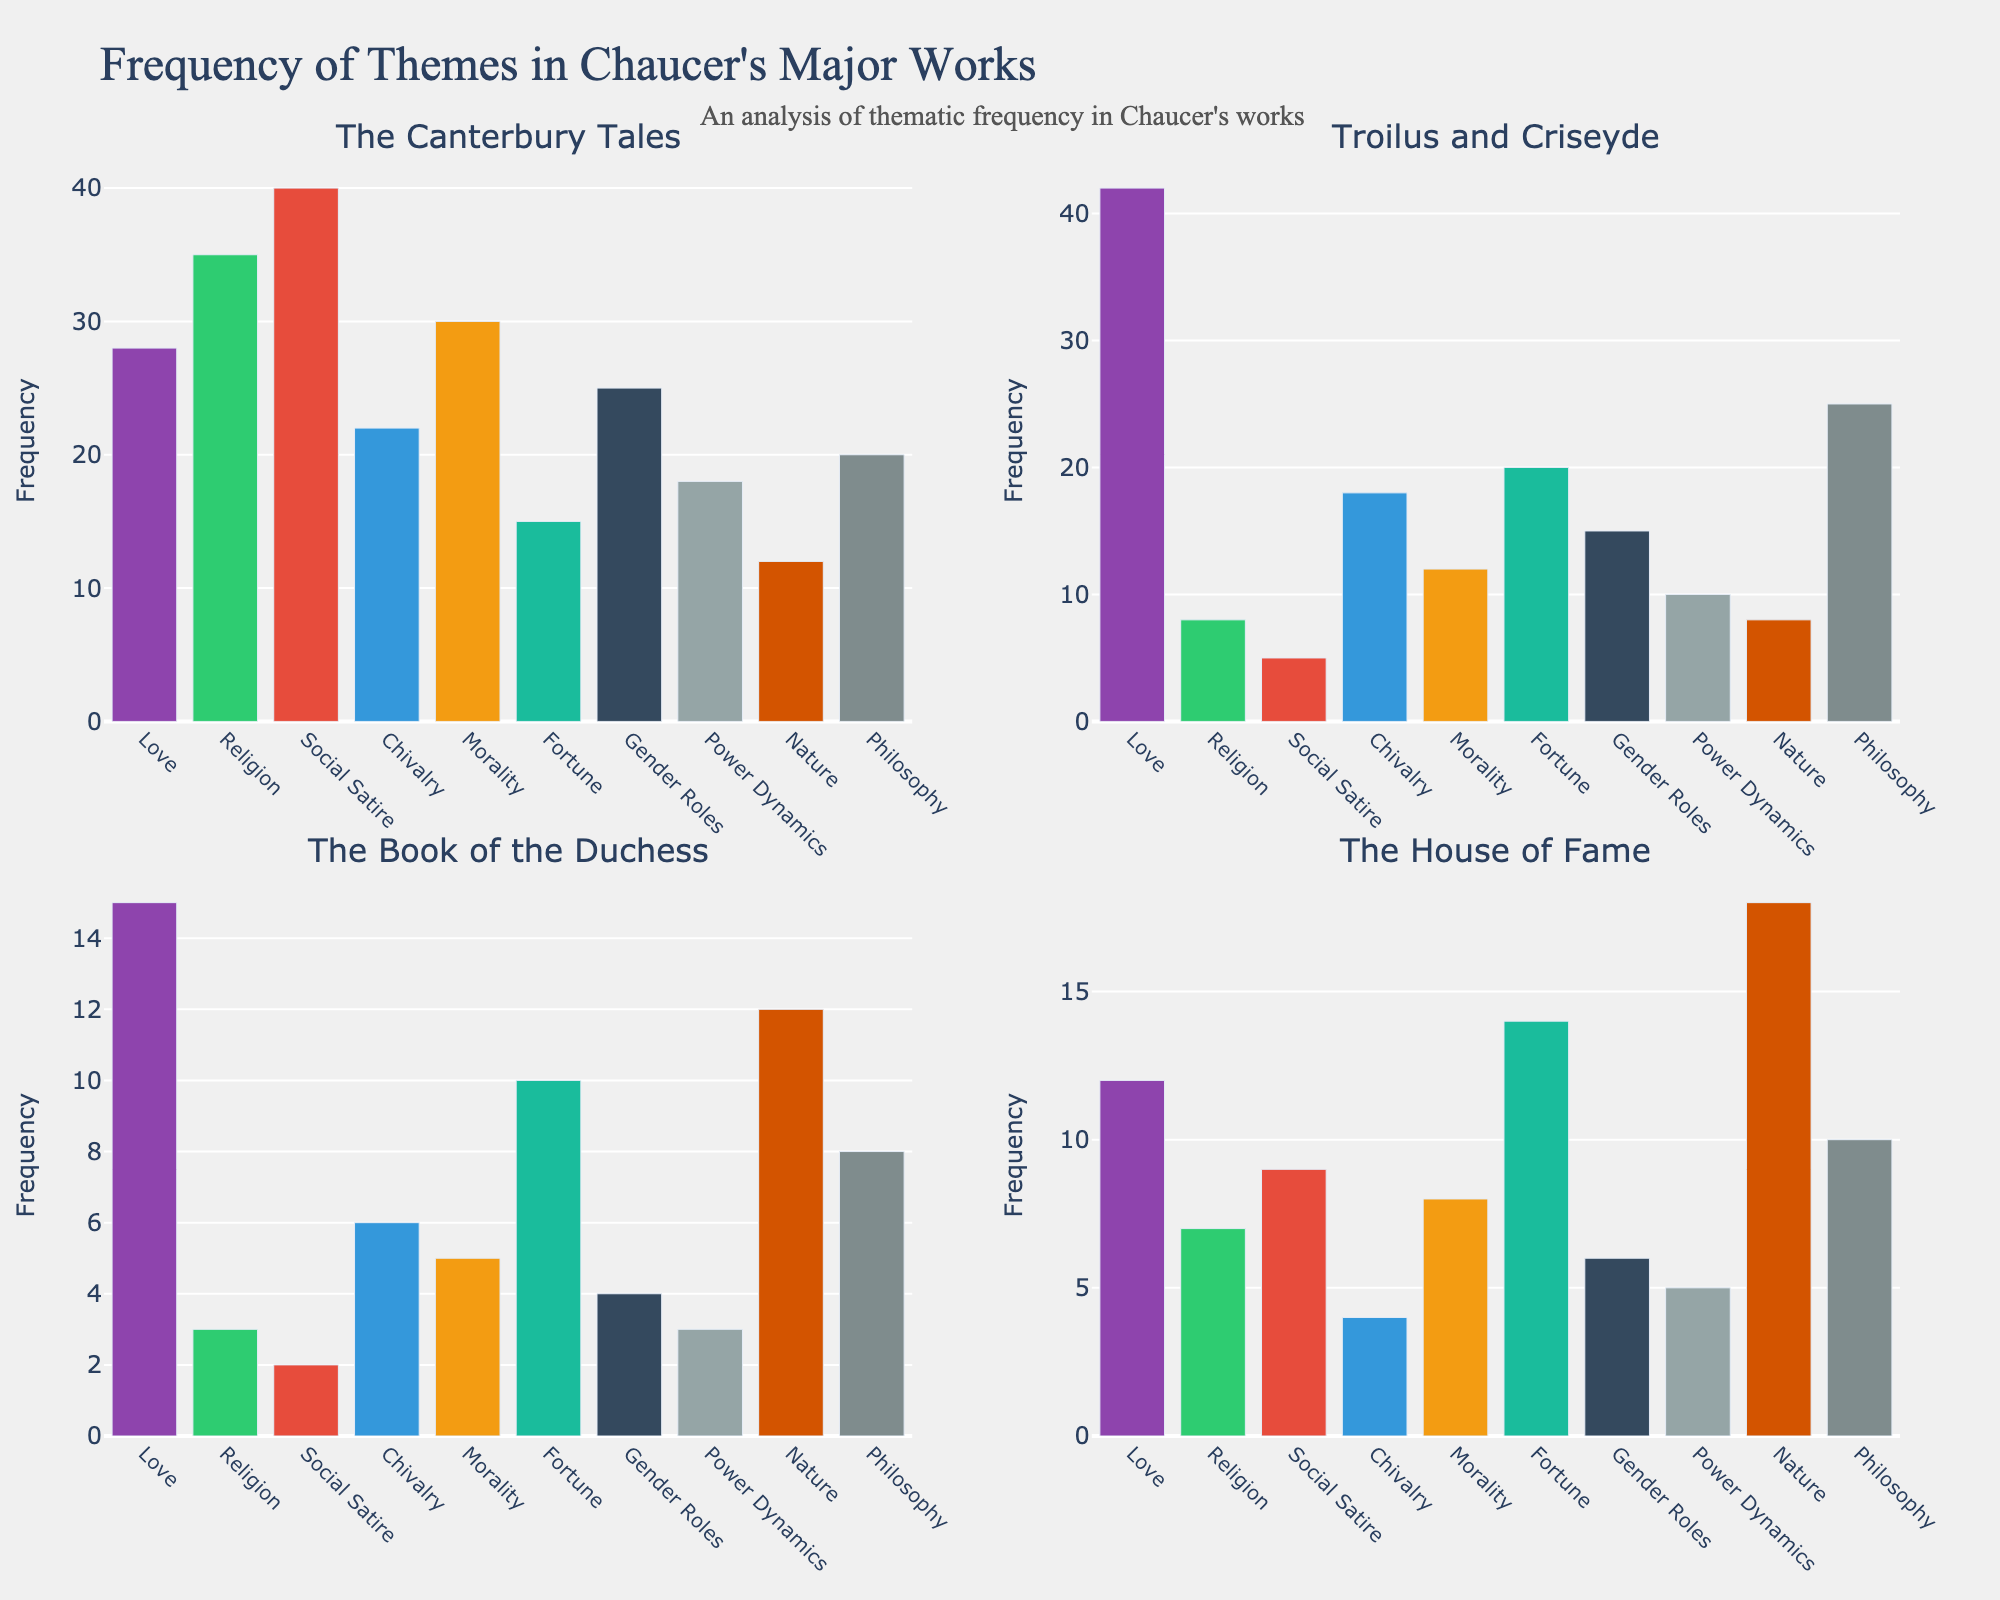Which theme appears most frequently in "The Canterbury Tales"? By examining the bar lengths for "The Canterbury Tales" subplot, we see that the "Social Satire" theme has the tallest bar, indicating the highest frequency.
Answer: Social Satire How many more times is the theme of "Love" discussed in "Troilus and Criseyde" compared to "The House of Fame"? In "Troilus and Criseyde," the frequency of "Love" is 42. In "The House of Fame," it is 12. The difference between them is 42 - 12 = 30.
Answer: 30 What is the sum of the frequencies of the "Religion" theme across all four works? Summing up the frequencies of "Religion" in each work: 35 (The Canterbury Tales) + 8 (Troilus and Criseyde) + 3 (The Book of the Duchess) + 7 (The House of Fame) = 53.
Answer: 53 Which theme is discussed with equal frequency in both "The Book of the Duchess" and "The House of Fame"? By visual inspection of the bars, we see that the "Nature" theme appears to have bars of equal height in both subplots. Counting the frequency, both have a frequency of 12.
Answer: Nature Based on the plot, compare the frequency of the "Chivalry" theme in "The Canterbury Tales" to "Troilus and Criseyde". Which one has a higher frequency and by how much? "The Canterbury Tales" has a frequency of 22 for "Chivalry," while "Troilus and Criseyde" has a frequency of 18. Thus, "The Canterbury Tales" has a higher frequency by 22 - 18 = 4.
Answer: The Canterbury Tales, by 4 What is the average frequency of the "Philosophy" theme across all four works? Adding the frequencies of "Philosophy" across the works gives 20 (The Canterbury Tales) + 25 (Troilus and Criseyde) + 8 (The Book of the Duchess) + 10 (The House of Fame) = 63. Dividing this sum by the number of works (4) yields an average: 63 / 4 = 15.75.
Answer: 15.75 Which theme has the lowest frequency in "Troilus and Criseyde"? Observing the bars in the subplot for "Troilus and Criseyde," the "Religion" theme has the shortest bar, indicating the lowest frequency, which is 8.
Answer: Religion How does the frequency of the "Gender Roles" theme in "The Canterbury Tales" compare to its frequency in "The Book of the Duchess"? The "Gender Roles" theme has a frequency of 25 in "The Canterbury Tales" and 4 in "The Book of the Duchess." Comparing the two, "The Canterbury Tales" has a higher frequency by 25 - 4 = 21.
Answer: The Canterbury Tales, by 21 